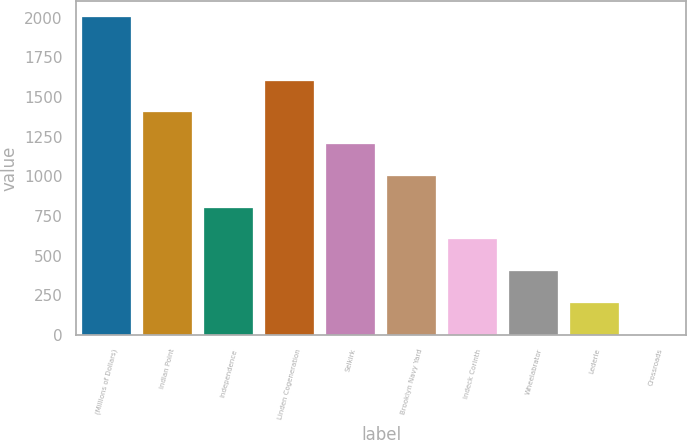<chart> <loc_0><loc_0><loc_500><loc_500><bar_chart><fcel>(Millions of Dollars)<fcel>Indian Point<fcel>Independence<fcel>Linden Cogeneration<fcel>Selkirk<fcel>Brooklyn Navy Yard<fcel>Indeck Corinth<fcel>Wheelabrator<fcel>Lederle<fcel>Crossroads<nl><fcel>2003<fcel>1402.7<fcel>802.4<fcel>1602.8<fcel>1202.6<fcel>1002.5<fcel>602.3<fcel>402.2<fcel>202.1<fcel>2<nl></chart> 